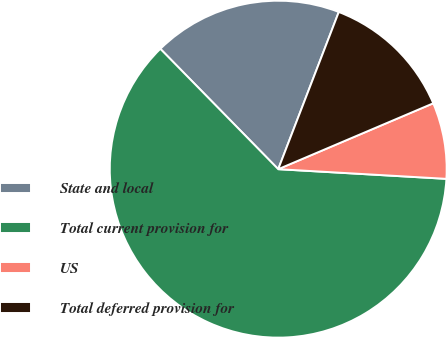Convert chart to OTSL. <chart><loc_0><loc_0><loc_500><loc_500><pie_chart><fcel>State and local<fcel>Total current provision for<fcel>US<fcel>Total deferred provision for<nl><fcel>18.19%<fcel>61.75%<fcel>7.31%<fcel>12.75%<nl></chart> 